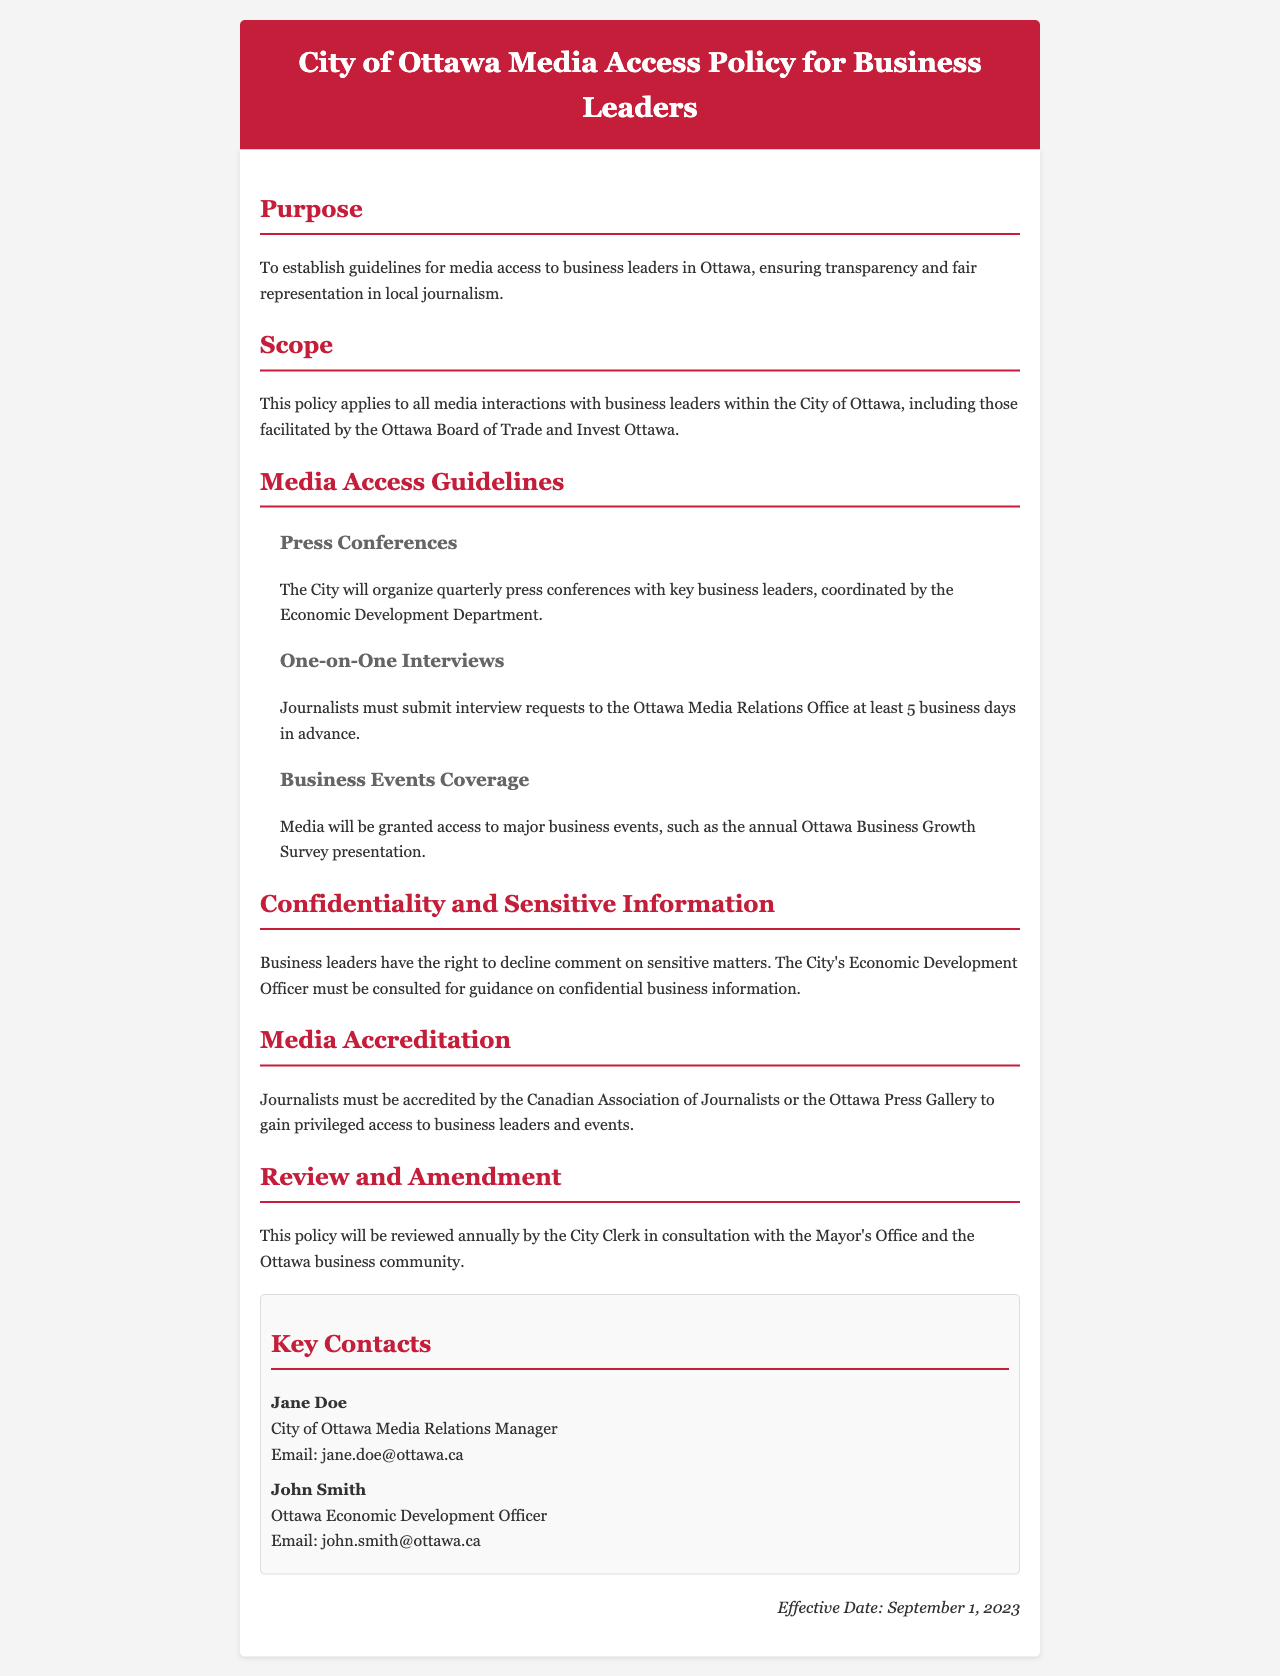what is the effective date of the policy? The effective date is mentioned towards the end of the document, indicating when the policy will be in effect.
Answer: September 1, 2023 who manages media relations for the City of Ottawa? The document lists Jane Doe as the City of Ottawa Media Relations Manager.
Answer: Jane Doe how many press conferences will the City organize each year? The policy specifically states that quarterly press conferences will be organized.
Answer: Quarterly what is required for journalists to gain privileged access? The policy outlines that journalists must be accredited by specific professional organizations to gain privileges.
Answer: Accredited how many business days in advance must interview requests be submitted? The document clearly states that requests need to be made 5 business days prior to the interview.
Answer: 5 who should be consulted regarding confidential business information? The document indicates that the City's Economic Development Officer must be consulted for such matters.
Answer: Economic Development Officer what is the primary purpose of the media access policy? The purpose section of the document outlines the main goal of establishing guidelines for media access.
Answer: Transparency and fair representation how often will the policy be reviewed? The document mentions that the policy will undergo an annual review process.
Answer: Annually 